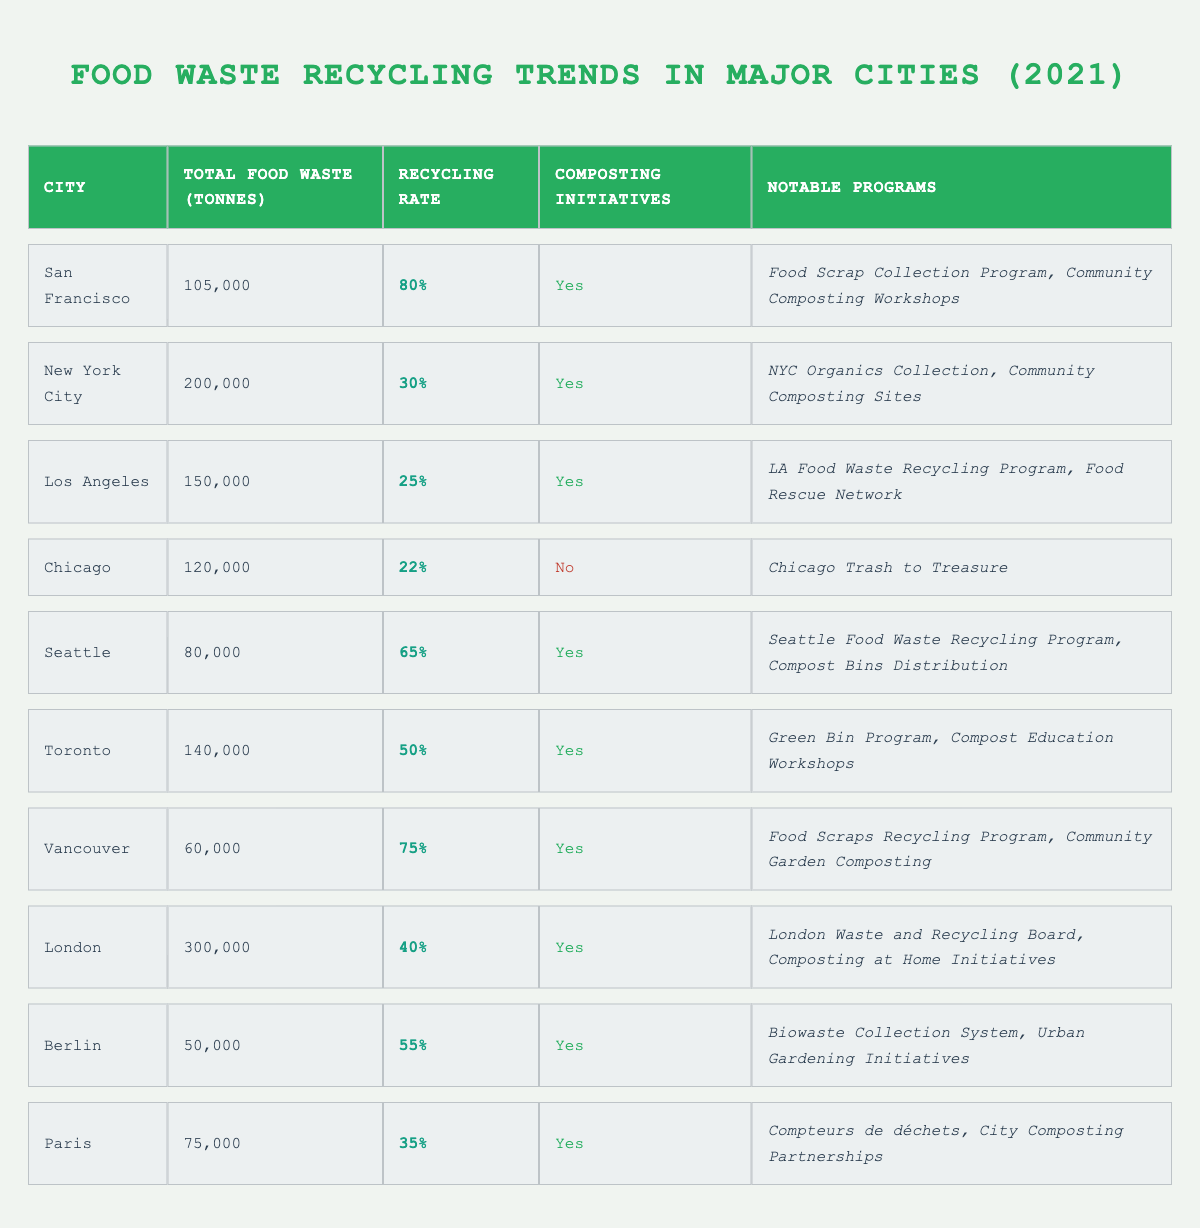What city had the highest recycling rate in 2021? Looking at the table, San Francisco has the highest recycling rate at 80%.
Answer: San Francisco How much food waste did Los Angeles produce in 2021? According to the table, Los Angeles produced 150,000 tonnes of food waste in 2021.
Answer: 150,000 tonnes Did Chicago have any composting initiatives in 2021? The table indicates that Chicago did not have any composting initiatives, as it states "No" in that column.
Answer: No What is the total food waste generated by Seattle and Toronto combined? To find the combined total, add Seattle’s 80,000 tonnes to Toronto’s 140,000 tonnes, which equals 220,000 tonnes.
Answer: 220,000 tonnes Which city generated the least amount of food waste in 2021? By scanning the total food waste column, Berlin generated the least at 50,000 tonnes.
Answer: Berlin What percentage of food waste was recycled in New York City? The table shows that New York City's recycling rate was 30%.
Answer: 30% How many notable programs did Vancouver and Seattle have together? Both Vancouver and Seattle had 2 notable programs each, so summing them gives a total of 4 notable programs.
Answer: 4 Which city has the same recycling rate as Paris? Both New York City and Paris have a recycling rate of 35%.
Answer: New York City Which city had a total food waste of 300,000 tonnes? The table states that London had the total food waste of 300,000 tonnes in 2021.
Answer: London Is there a city that did not have composting initiatives but maintained a reasonable recycling rate? Yes, Chicago did not have composting initiatives and had a recycling rate of 22%, which is relatively low compared to others.
Answer: Yes What is the average recycling rate for cities that implemented composting initiatives? The cities with composting initiatives are San Francisco (80%), New York City (30%), Los Angeles (25%), Seattle (65%), Toronto (50%), Vancouver (75%), London (40%), Berlin (55%), and Paris (35%). The average is calculated by adding these rates and dividing by 9, which results in an average recycling rate of approximately 52.5%.
Answer: 52.5% How many cities had a recycling rate below 30%? Los Angeles and Chicago are the only cities with recycling rates below 30% at 25% and 22%, respectively; thus, there are two cities.
Answer: 2 What notable programs did the city with the highest recycling rate in 2021 have? San Francisco, having the highest recycling rate, featured notable programs such as the Food Scrap Collection Program and Community Composting Workshops.
Answer: Food Scrap Collection Program, Community Composting Workshops 